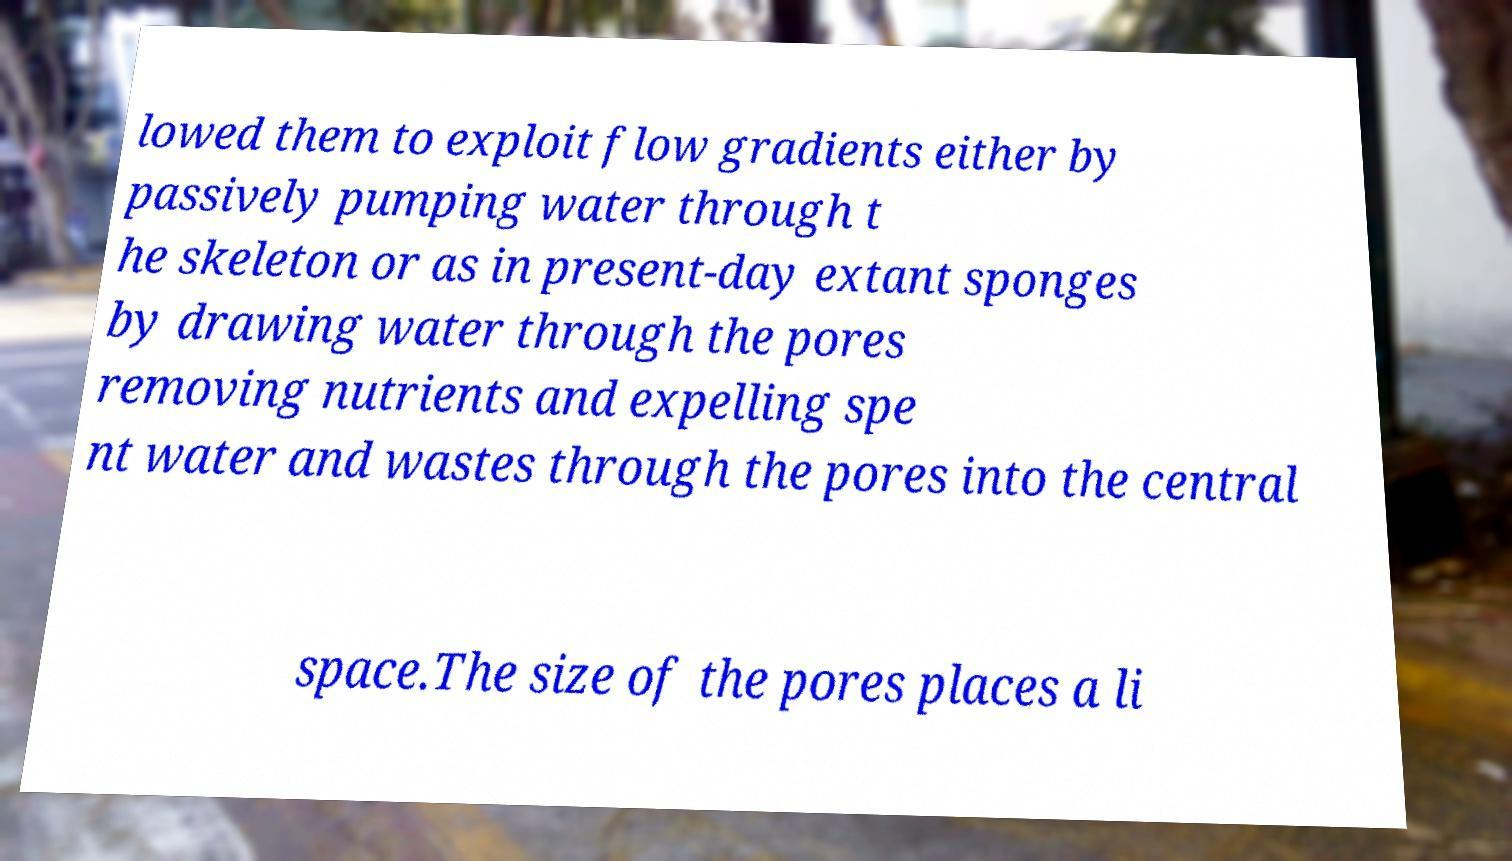Could you assist in decoding the text presented in this image and type it out clearly? lowed them to exploit flow gradients either by passively pumping water through t he skeleton or as in present-day extant sponges by drawing water through the pores removing nutrients and expelling spe nt water and wastes through the pores into the central space.The size of the pores places a li 